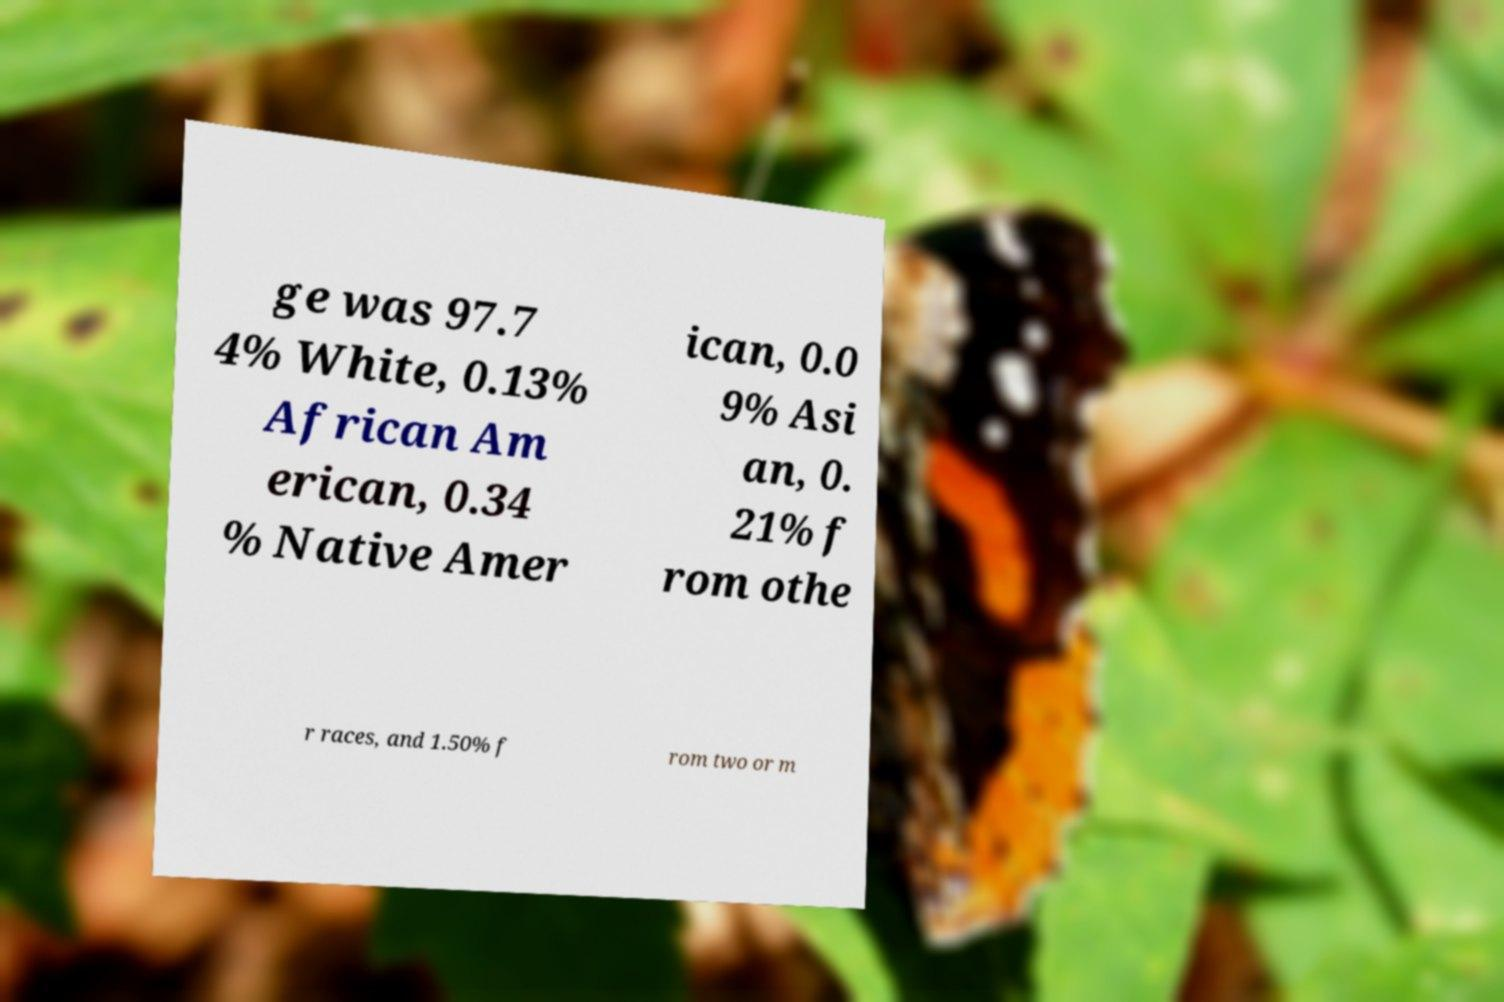Could you assist in decoding the text presented in this image and type it out clearly? ge was 97.7 4% White, 0.13% African Am erican, 0.34 % Native Amer ican, 0.0 9% Asi an, 0. 21% f rom othe r races, and 1.50% f rom two or m 